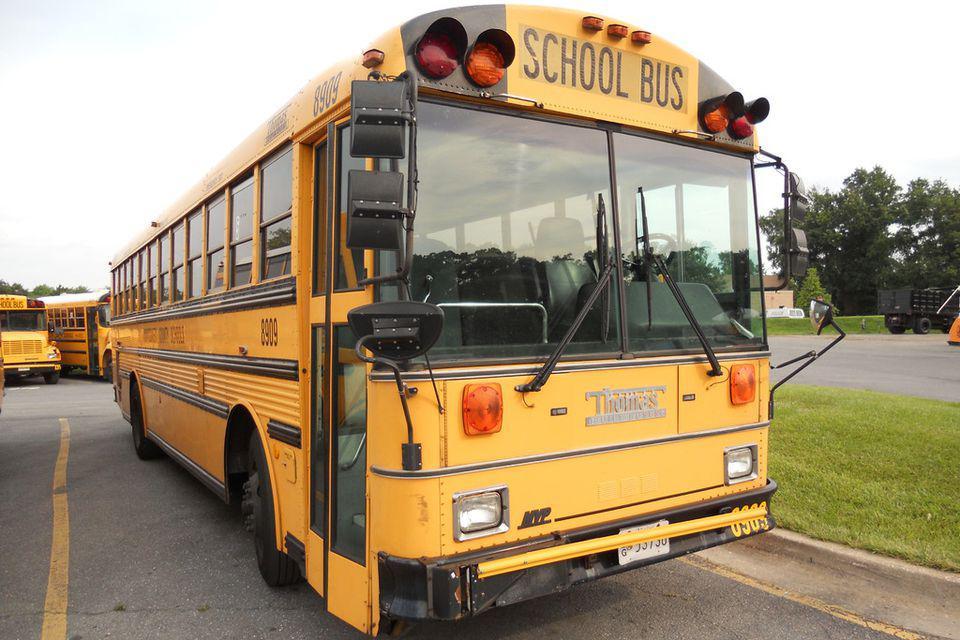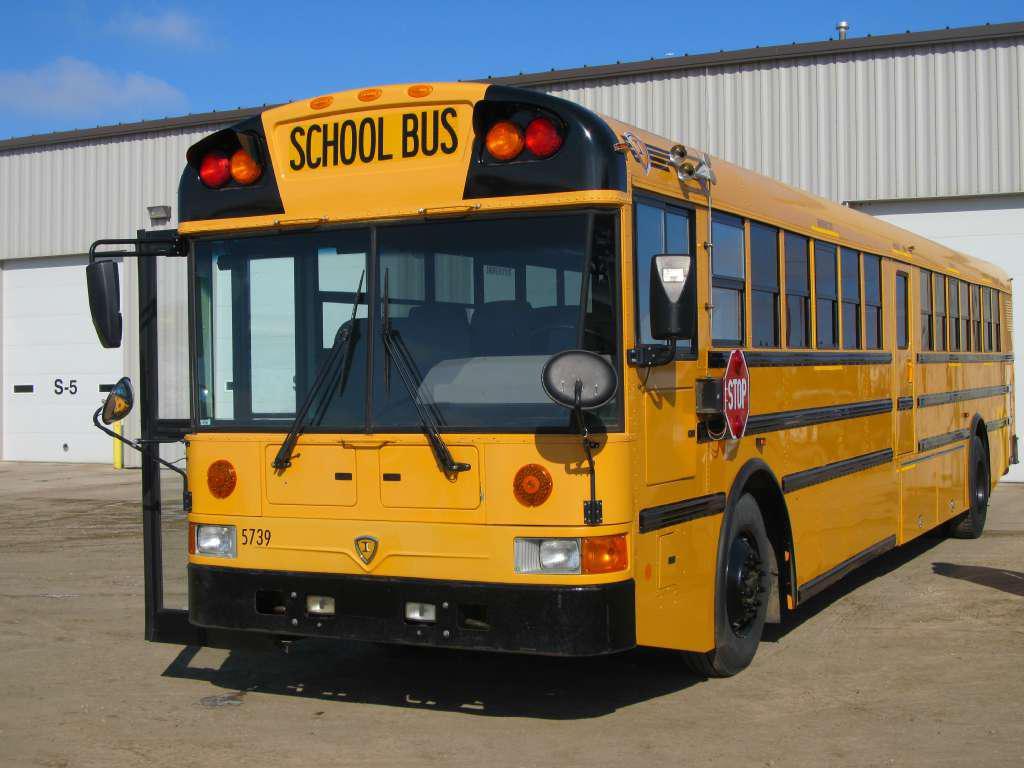The first image is the image on the left, the second image is the image on the right. For the images shown, is this caption "The school buses in both pictures are facing left." true? Answer yes or no. No. The first image is the image on the left, the second image is the image on the right. Considering the images on both sides, is "One of the images features two school buses beside each other and the other image shows a single school bus." valid? Answer yes or no. No. 